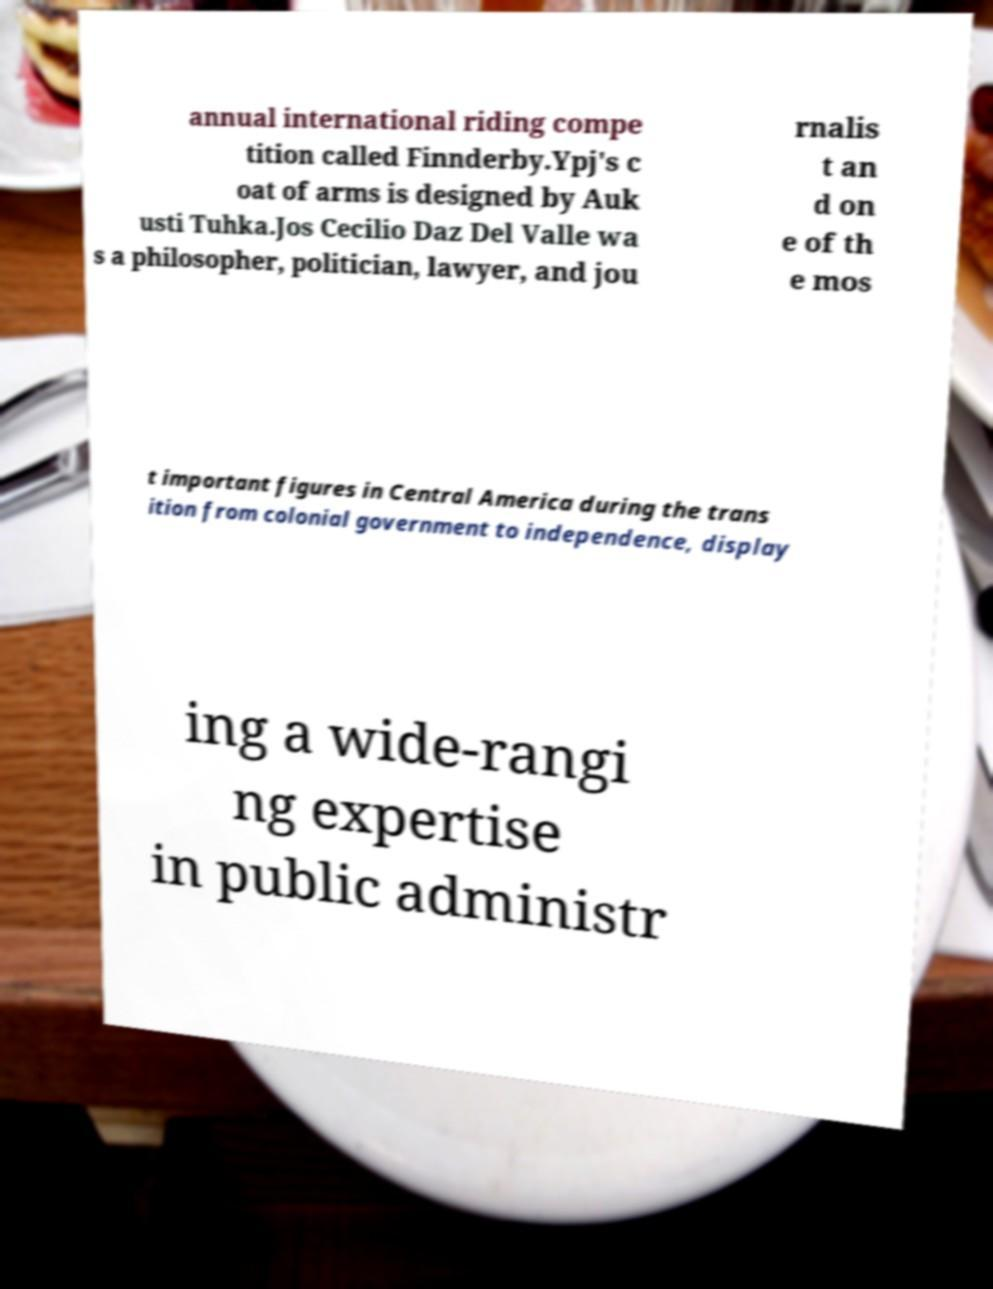Could you assist in decoding the text presented in this image and type it out clearly? annual international riding compe tition called Finnderby.Ypj's c oat of arms is designed by Auk usti Tuhka.Jos Cecilio Daz Del Valle wa s a philosopher, politician, lawyer, and jou rnalis t an d on e of th e mos t important figures in Central America during the trans ition from colonial government to independence, display ing a wide-rangi ng expertise in public administr 